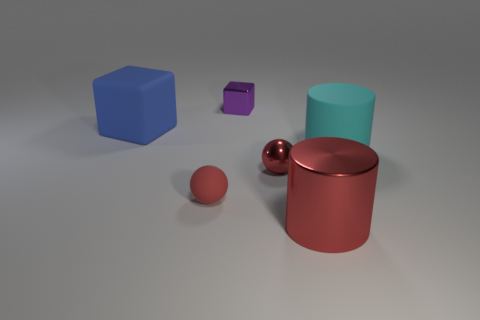Are there fewer rubber blocks that are in front of the cyan cylinder than tiny things?
Offer a very short reply. Yes. How big is the matte object that is on the right side of the large red metallic cylinder?
Keep it short and to the point. Large. There is another rubber thing that is the same shape as the big red thing; what color is it?
Your response must be concise. Cyan. What number of other large matte cylinders have the same color as the big rubber cylinder?
Your answer should be compact. 0. Are there any other things that are the same shape as the purple metal object?
Offer a terse response. Yes. Is there a small purple metallic block that is to the left of the tiny object behind the cylinder that is behind the tiny metallic sphere?
Your response must be concise. No. How many small blocks have the same material as the cyan cylinder?
Your response must be concise. 0. There is a cylinder in front of the cyan rubber object; is its size the same as the red object that is behind the rubber sphere?
Give a very brief answer. No. The large thing that is behind the rubber cylinder that is in front of the purple block to the left of the cyan matte cylinder is what color?
Ensure brevity in your answer.  Blue. Are there any big blue rubber things of the same shape as the cyan thing?
Keep it short and to the point. No. 